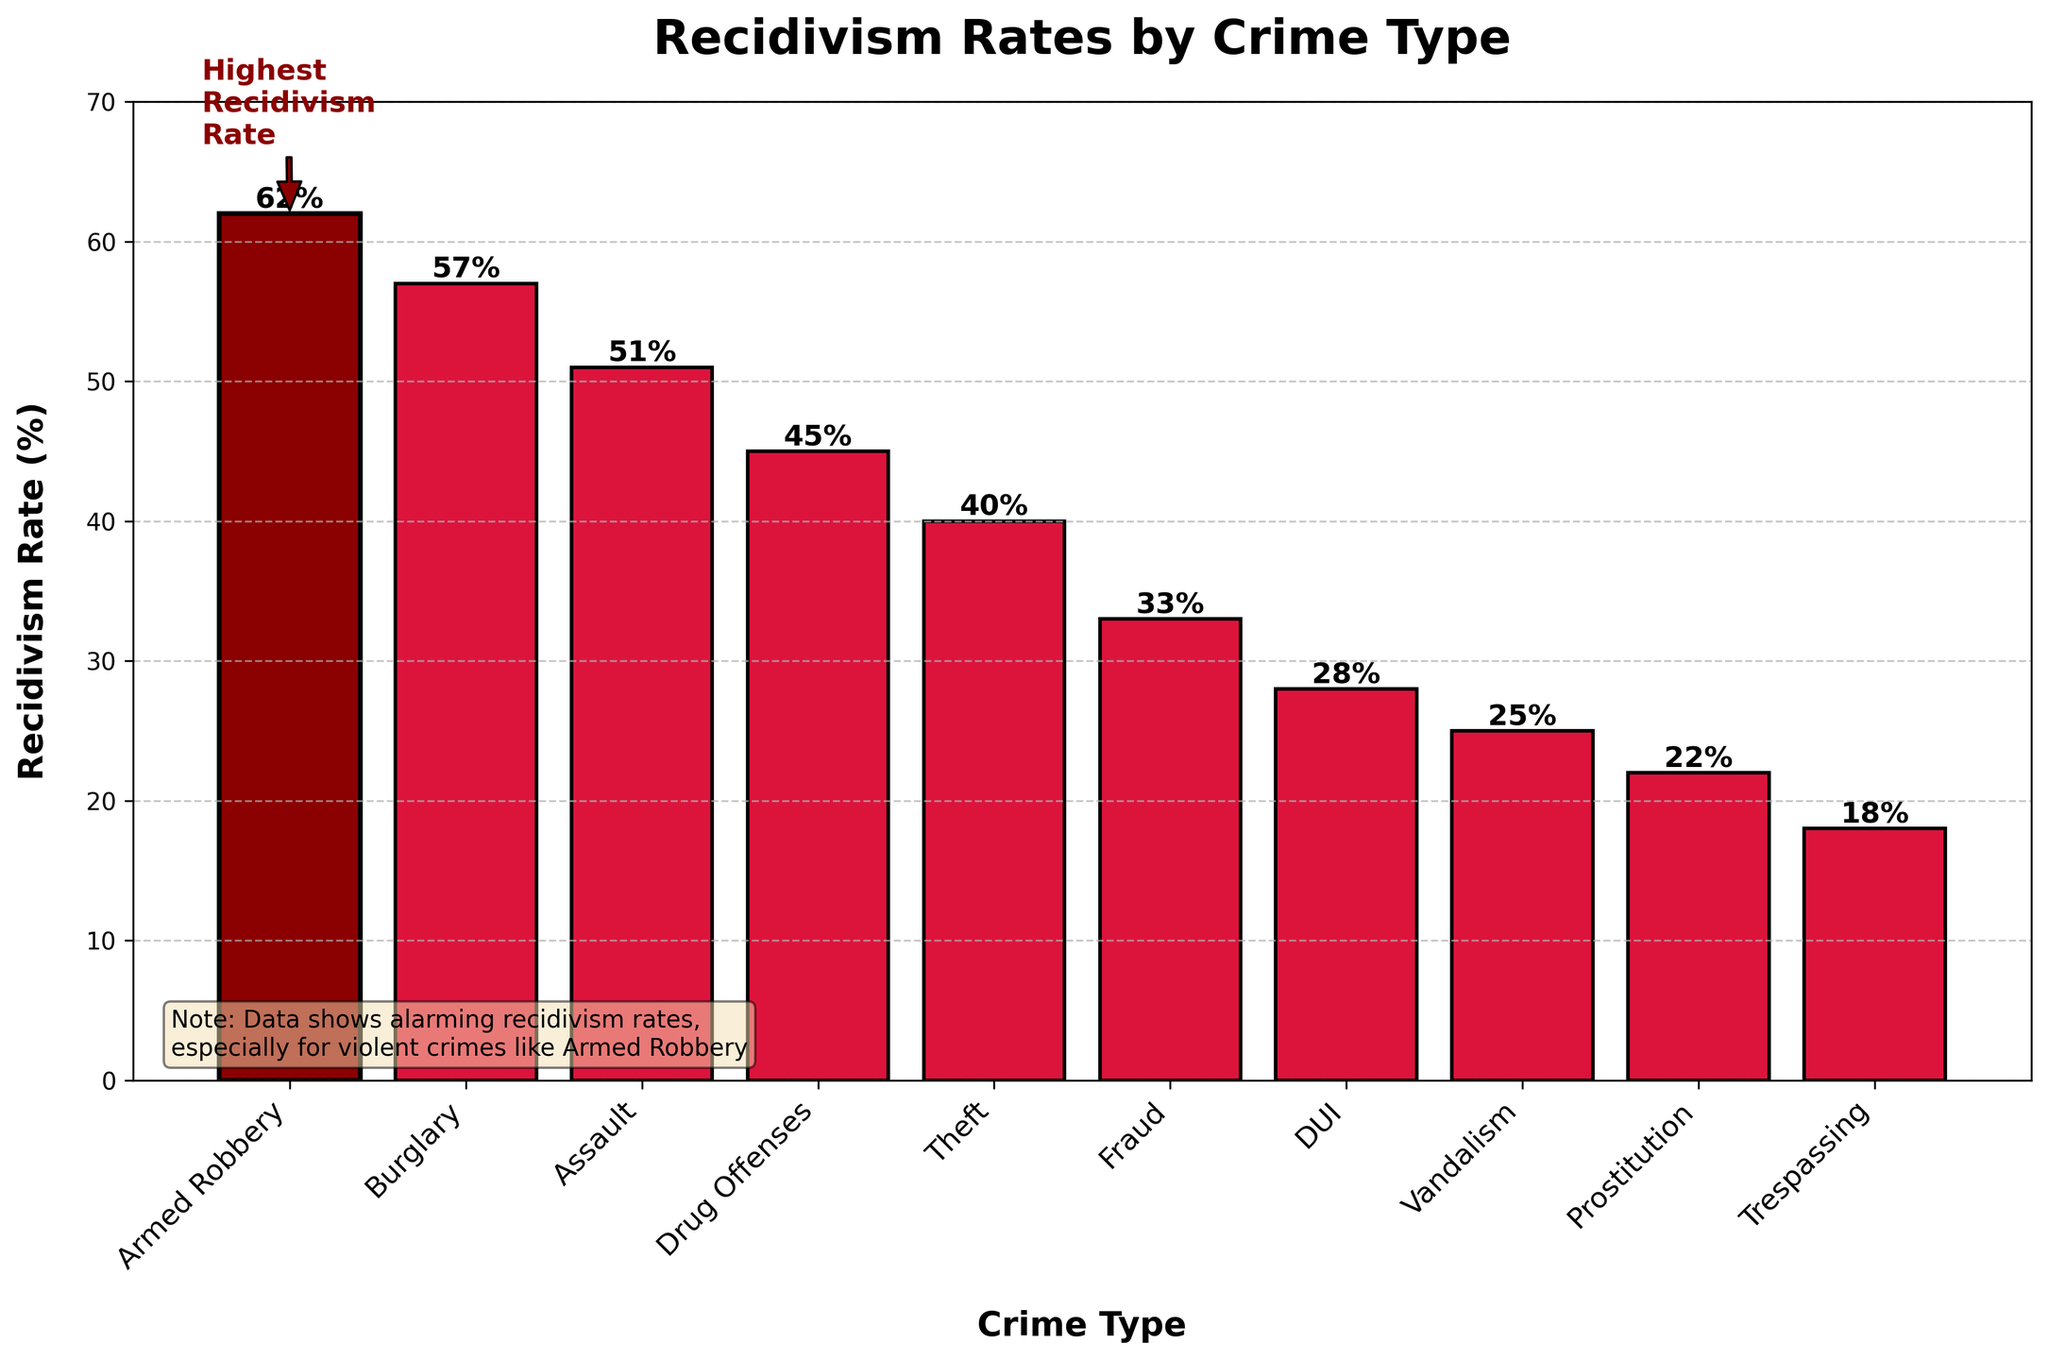What crime type has the highest recidivism rate? By looking at the chart, the highest bar will indicate the crime type with the highest recidivism rate. The 'Armed Robbery' bar is marked distinctively and has the highest value.
Answer: Armed Robbery What is the difference in recidivism rates between Assault and Theft? The recidivism rate for Assault is 51%, and for Theft, it's 40%. The difference is calculated as 51% - 40%.
Answer: 11% How many crime types have a recidivism rate lower than 30%? By observing the bars below the 30% mark, we count the relevant crime types. Trespassing, Prostitution, and Vandalism fall below this threshold.
Answer: 3 What is the average recidivism rate of Fraud, DUI, and Vandalism? Add the recidivism rates for Fraud (33%), DUI (28%), and Vandalism (25%), then divide by 3 to find the average: (33 + 28 + 25) / 3.
Answer: 28.7% Which crime type has a recidivism rate closest to the median of all listed rates? Sorting the rates (18, 22, 25, 28, 33, 40, 45, 51, 57, 62), the median falls between 40 and 45. Drug Offenses at 45% is closest to this median.
Answer: Drug Offenses Is the recidivism rate for Burglary higher or lower than that for Assault? Compare the heights of the bars for Burglary (57%) and Assault (51%). Since 57% is greater than 51%, Burglary has a higher rate.
Answer: Higher Identify the crime type with the lowest recidivism rate. The shortest bar indicates the lowest recidivism rate. Trespassing is at the bottom with 18%.
Answer: Trespassing What is the combined recidivism rate for Prostitution and Trespassing? Add the rates for Prostitution (22%) and Trespassing (18%) for the combined value.
Answer: 40% How much higher is the recidivism rate for Armed Robbery compared to Vandalism? Subtract the recidivism rate of Vandalism (25%) from that of Armed Robbery (62%) to find the difference.
Answer: 37% Which bars are shown in dark red color and why? 'Armed Robbery' is highlighted in dark red to indicate that it has the highest recidivism rate.
Answer: Armed Robbery 